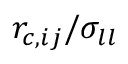Convert formula to latex. <formula><loc_0><loc_0><loc_500><loc_500>r _ { c , i j } / \sigma _ { l l }</formula> 